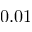Convert formula to latex. <formula><loc_0><loc_0><loc_500><loc_500>0 . 0 1</formula> 